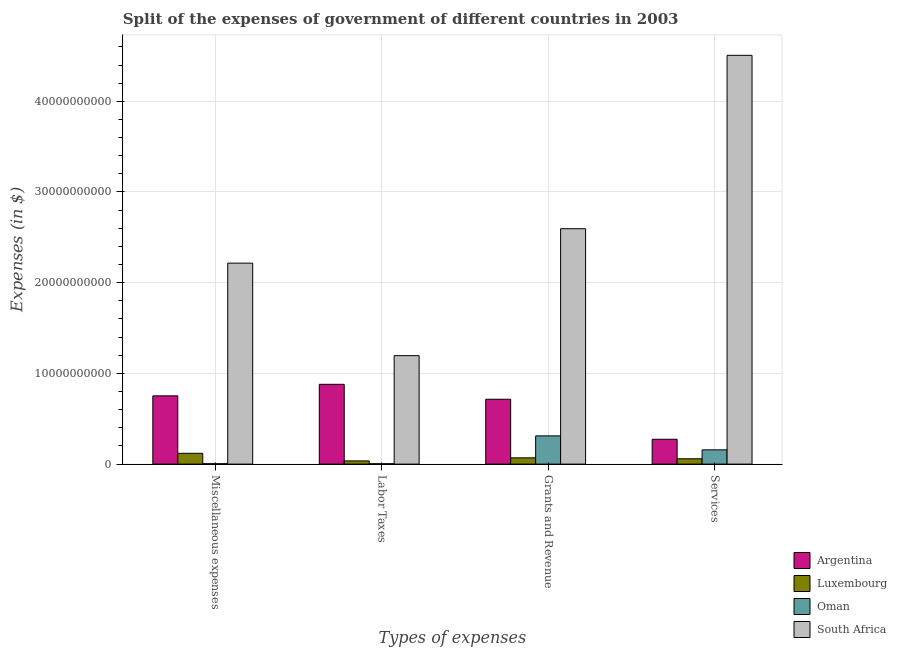How many different coloured bars are there?
Make the answer very short. 4. Are the number of bars on each tick of the X-axis equal?
Your response must be concise. Yes. How many bars are there on the 2nd tick from the left?
Provide a short and direct response. 4. How many bars are there on the 2nd tick from the right?
Ensure brevity in your answer.  4. What is the label of the 2nd group of bars from the left?
Make the answer very short. Labor Taxes. What is the amount spent on grants and revenue in South Africa?
Offer a very short reply. 2.60e+1. Across all countries, what is the maximum amount spent on services?
Keep it short and to the point. 4.51e+1. Across all countries, what is the minimum amount spent on labor taxes?
Keep it short and to the point. 4.31e+07. In which country was the amount spent on miscellaneous expenses maximum?
Offer a very short reply. South Africa. In which country was the amount spent on grants and revenue minimum?
Keep it short and to the point. Luxembourg. What is the total amount spent on labor taxes in the graph?
Your response must be concise. 2.12e+1. What is the difference between the amount spent on labor taxes in Luxembourg and that in Oman?
Your answer should be compact. 3.11e+08. What is the difference between the amount spent on labor taxes in Luxembourg and the amount spent on miscellaneous expenses in Oman?
Provide a succinct answer. 3.12e+08. What is the average amount spent on grants and revenue per country?
Your answer should be very brief. 9.23e+09. What is the difference between the amount spent on labor taxes and amount spent on grants and revenue in Oman?
Make the answer very short. -3.07e+09. In how many countries, is the amount spent on labor taxes greater than 22000000000 $?
Give a very brief answer. 0. What is the ratio of the amount spent on grants and revenue in Oman to that in Luxembourg?
Provide a short and direct response. 4.5. Is the amount spent on services in Argentina less than that in Oman?
Provide a short and direct response. No. Is the difference between the amount spent on miscellaneous expenses in Oman and Argentina greater than the difference between the amount spent on labor taxes in Oman and Argentina?
Your answer should be compact. Yes. What is the difference between the highest and the second highest amount spent on grants and revenue?
Your response must be concise. 1.88e+1. What is the difference between the highest and the lowest amount spent on services?
Your answer should be compact. 4.45e+1. What does the 4th bar from the right in Labor Taxes represents?
Offer a very short reply. Argentina. Is it the case that in every country, the sum of the amount spent on miscellaneous expenses and amount spent on labor taxes is greater than the amount spent on grants and revenue?
Your answer should be compact. No. How many bars are there?
Keep it short and to the point. 16. Are all the bars in the graph horizontal?
Offer a terse response. No. How many countries are there in the graph?
Your answer should be compact. 4. What is the difference between two consecutive major ticks on the Y-axis?
Offer a very short reply. 1.00e+1. Are the values on the major ticks of Y-axis written in scientific E-notation?
Provide a short and direct response. No. Where does the legend appear in the graph?
Your answer should be very brief. Bottom right. How are the legend labels stacked?
Provide a succinct answer. Vertical. What is the title of the graph?
Keep it short and to the point. Split of the expenses of government of different countries in 2003. What is the label or title of the X-axis?
Offer a terse response. Types of expenses. What is the label or title of the Y-axis?
Ensure brevity in your answer.  Expenses (in $). What is the Expenses (in $) in Argentina in Miscellaneous expenses?
Your answer should be very brief. 7.53e+09. What is the Expenses (in $) in Luxembourg in Miscellaneous expenses?
Your answer should be compact. 1.19e+09. What is the Expenses (in $) in Oman in Miscellaneous expenses?
Provide a succinct answer. 4.27e+07. What is the Expenses (in $) of South Africa in Miscellaneous expenses?
Your response must be concise. 2.22e+1. What is the Expenses (in $) of Argentina in Labor Taxes?
Offer a very short reply. 8.80e+09. What is the Expenses (in $) in Luxembourg in Labor Taxes?
Give a very brief answer. 3.54e+08. What is the Expenses (in $) of Oman in Labor Taxes?
Your answer should be compact. 4.31e+07. What is the Expenses (in $) of South Africa in Labor Taxes?
Offer a very short reply. 1.20e+1. What is the Expenses (in $) of Argentina in Grants and Revenue?
Offer a terse response. 7.15e+09. What is the Expenses (in $) in Luxembourg in Grants and Revenue?
Your answer should be very brief. 6.93e+08. What is the Expenses (in $) in Oman in Grants and Revenue?
Ensure brevity in your answer.  3.11e+09. What is the Expenses (in $) of South Africa in Grants and Revenue?
Provide a short and direct response. 2.60e+1. What is the Expenses (in $) in Argentina in Services?
Make the answer very short. 2.74e+09. What is the Expenses (in $) in Luxembourg in Services?
Keep it short and to the point. 5.89e+08. What is the Expenses (in $) in Oman in Services?
Make the answer very short. 1.57e+09. What is the Expenses (in $) in South Africa in Services?
Your response must be concise. 4.51e+1. Across all Types of expenses, what is the maximum Expenses (in $) of Argentina?
Keep it short and to the point. 8.80e+09. Across all Types of expenses, what is the maximum Expenses (in $) of Luxembourg?
Offer a terse response. 1.19e+09. Across all Types of expenses, what is the maximum Expenses (in $) in Oman?
Ensure brevity in your answer.  3.11e+09. Across all Types of expenses, what is the maximum Expenses (in $) in South Africa?
Give a very brief answer. 4.51e+1. Across all Types of expenses, what is the minimum Expenses (in $) of Argentina?
Give a very brief answer. 2.74e+09. Across all Types of expenses, what is the minimum Expenses (in $) of Luxembourg?
Keep it short and to the point. 3.54e+08. Across all Types of expenses, what is the minimum Expenses (in $) in Oman?
Offer a terse response. 4.27e+07. Across all Types of expenses, what is the minimum Expenses (in $) in South Africa?
Your answer should be compact. 1.20e+1. What is the total Expenses (in $) of Argentina in the graph?
Ensure brevity in your answer.  2.62e+1. What is the total Expenses (in $) in Luxembourg in the graph?
Provide a short and direct response. 2.83e+09. What is the total Expenses (in $) in Oman in the graph?
Provide a short and direct response. 4.77e+09. What is the total Expenses (in $) of South Africa in the graph?
Offer a terse response. 1.05e+11. What is the difference between the Expenses (in $) of Argentina in Miscellaneous expenses and that in Labor Taxes?
Provide a short and direct response. -1.27e+09. What is the difference between the Expenses (in $) of Luxembourg in Miscellaneous expenses and that in Labor Taxes?
Make the answer very short. 8.38e+08. What is the difference between the Expenses (in $) of Oman in Miscellaneous expenses and that in Labor Taxes?
Your response must be concise. -4.00e+05. What is the difference between the Expenses (in $) in South Africa in Miscellaneous expenses and that in Labor Taxes?
Give a very brief answer. 1.02e+1. What is the difference between the Expenses (in $) of Argentina in Miscellaneous expenses and that in Grants and Revenue?
Make the answer very short. 3.75e+08. What is the difference between the Expenses (in $) of Luxembourg in Miscellaneous expenses and that in Grants and Revenue?
Your answer should be compact. 5.00e+08. What is the difference between the Expenses (in $) of Oman in Miscellaneous expenses and that in Grants and Revenue?
Your answer should be very brief. -3.07e+09. What is the difference between the Expenses (in $) of South Africa in Miscellaneous expenses and that in Grants and Revenue?
Give a very brief answer. -3.80e+09. What is the difference between the Expenses (in $) of Argentina in Miscellaneous expenses and that in Services?
Provide a short and direct response. 4.79e+09. What is the difference between the Expenses (in $) in Luxembourg in Miscellaneous expenses and that in Services?
Ensure brevity in your answer.  6.04e+08. What is the difference between the Expenses (in $) of Oman in Miscellaneous expenses and that in Services?
Offer a very short reply. -1.53e+09. What is the difference between the Expenses (in $) in South Africa in Miscellaneous expenses and that in Services?
Offer a very short reply. -2.29e+1. What is the difference between the Expenses (in $) in Argentina in Labor Taxes and that in Grants and Revenue?
Ensure brevity in your answer.  1.65e+09. What is the difference between the Expenses (in $) of Luxembourg in Labor Taxes and that in Grants and Revenue?
Your answer should be compact. -3.38e+08. What is the difference between the Expenses (in $) in Oman in Labor Taxes and that in Grants and Revenue?
Your answer should be very brief. -3.07e+09. What is the difference between the Expenses (in $) of South Africa in Labor Taxes and that in Grants and Revenue?
Make the answer very short. -1.40e+1. What is the difference between the Expenses (in $) in Argentina in Labor Taxes and that in Services?
Offer a terse response. 6.06e+09. What is the difference between the Expenses (in $) of Luxembourg in Labor Taxes and that in Services?
Your answer should be very brief. -2.34e+08. What is the difference between the Expenses (in $) in Oman in Labor Taxes and that in Services?
Ensure brevity in your answer.  -1.53e+09. What is the difference between the Expenses (in $) in South Africa in Labor Taxes and that in Services?
Provide a short and direct response. -3.31e+1. What is the difference between the Expenses (in $) of Argentina in Grants and Revenue and that in Services?
Ensure brevity in your answer.  4.41e+09. What is the difference between the Expenses (in $) in Luxembourg in Grants and Revenue and that in Services?
Give a very brief answer. 1.04e+08. What is the difference between the Expenses (in $) in Oman in Grants and Revenue and that in Services?
Ensure brevity in your answer.  1.54e+09. What is the difference between the Expenses (in $) in South Africa in Grants and Revenue and that in Services?
Provide a succinct answer. -1.91e+1. What is the difference between the Expenses (in $) in Argentina in Miscellaneous expenses and the Expenses (in $) in Luxembourg in Labor Taxes?
Provide a short and direct response. 7.17e+09. What is the difference between the Expenses (in $) of Argentina in Miscellaneous expenses and the Expenses (in $) of Oman in Labor Taxes?
Provide a short and direct response. 7.48e+09. What is the difference between the Expenses (in $) in Argentina in Miscellaneous expenses and the Expenses (in $) in South Africa in Labor Taxes?
Make the answer very short. -4.43e+09. What is the difference between the Expenses (in $) of Luxembourg in Miscellaneous expenses and the Expenses (in $) of Oman in Labor Taxes?
Make the answer very short. 1.15e+09. What is the difference between the Expenses (in $) of Luxembourg in Miscellaneous expenses and the Expenses (in $) of South Africa in Labor Taxes?
Your answer should be compact. -1.08e+1. What is the difference between the Expenses (in $) in Oman in Miscellaneous expenses and the Expenses (in $) in South Africa in Labor Taxes?
Provide a succinct answer. -1.19e+1. What is the difference between the Expenses (in $) of Argentina in Miscellaneous expenses and the Expenses (in $) of Luxembourg in Grants and Revenue?
Your answer should be very brief. 6.83e+09. What is the difference between the Expenses (in $) in Argentina in Miscellaneous expenses and the Expenses (in $) in Oman in Grants and Revenue?
Your response must be concise. 4.41e+09. What is the difference between the Expenses (in $) in Argentina in Miscellaneous expenses and the Expenses (in $) in South Africa in Grants and Revenue?
Provide a succinct answer. -1.84e+1. What is the difference between the Expenses (in $) in Luxembourg in Miscellaneous expenses and the Expenses (in $) in Oman in Grants and Revenue?
Offer a very short reply. -1.92e+09. What is the difference between the Expenses (in $) of Luxembourg in Miscellaneous expenses and the Expenses (in $) of South Africa in Grants and Revenue?
Offer a terse response. -2.48e+1. What is the difference between the Expenses (in $) of Oman in Miscellaneous expenses and the Expenses (in $) of South Africa in Grants and Revenue?
Your answer should be compact. -2.59e+1. What is the difference between the Expenses (in $) of Argentina in Miscellaneous expenses and the Expenses (in $) of Luxembourg in Services?
Your answer should be very brief. 6.94e+09. What is the difference between the Expenses (in $) of Argentina in Miscellaneous expenses and the Expenses (in $) of Oman in Services?
Your response must be concise. 5.95e+09. What is the difference between the Expenses (in $) in Argentina in Miscellaneous expenses and the Expenses (in $) in South Africa in Services?
Your response must be concise. -3.75e+1. What is the difference between the Expenses (in $) in Luxembourg in Miscellaneous expenses and the Expenses (in $) in Oman in Services?
Your response must be concise. -3.81e+08. What is the difference between the Expenses (in $) of Luxembourg in Miscellaneous expenses and the Expenses (in $) of South Africa in Services?
Provide a succinct answer. -4.39e+1. What is the difference between the Expenses (in $) in Oman in Miscellaneous expenses and the Expenses (in $) in South Africa in Services?
Make the answer very short. -4.50e+1. What is the difference between the Expenses (in $) of Argentina in Labor Taxes and the Expenses (in $) of Luxembourg in Grants and Revenue?
Your answer should be compact. 8.10e+09. What is the difference between the Expenses (in $) in Argentina in Labor Taxes and the Expenses (in $) in Oman in Grants and Revenue?
Provide a short and direct response. 5.68e+09. What is the difference between the Expenses (in $) in Argentina in Labor Taxes and the Expenses (in $) in South Africa in Grants and Revenue?
Provide a succinct answer. -1.72e+1. What is the difference between the Expenses (in $) in Luxembourg in Labor Taxes and the Expenses (in $) in Oman in Grants and Revenue?
Offer a very short reply. -2.76e+09. What is the difference between the Expenses (in $) of Luxembourg in Labor Taxes and the Expenses (in $) of South Africa in Grants and Revenue?
Offer a very short reply. -2.56e+1. What is the difference between the Expenses (in $) of Oman in Labor Taxes and the Expenses (in $) of South Africa in Grants and Revenue?
Your answer should be compact. -2.59e+1. What is the difference between the Expenses (in $) of Argentina in Labor Taxes and the Expenses (in $) of Luxembourg in Services?
Ensure brevity in your answer.  8.21e+09. What is the difference between the Expenses (in $) of Argentina in Labor Taxes and the Expenses (in $) of Oman in Services?
Give a very brief answer. 7.22e+09. What is the difference between the Expenses (in $) of Argentina in Labor Taxes and the Expenses (in $) of South Africa in Services?
Offer a very short reply. -3.63e+1. What is the difference between the Expenses (in $) of Luxembourg in Labor Taxes and the Expenses (in $) of Oman in Services?
Your answer should be very brief. -1.22e+09. What is the difference between the Expenses (in $) in Luxembourg in Labor Taxes and the Expenses (in $) in South Africa in Services?
Give a very brief answer. -4.47e+1. What is the difference between the Expenses (in $) in Oman in Labor Taxes and the Expenses (in $) in South Africa in Services?
Your response must be concise. -4.50e+1. What is the difference between the Expenses (in $) in Argentina in Grants and Revenue and the Expenses (in $) in Luxembourg in Services?
Provide a short and direct response. 6.56e+09. What is the difference between the Expenses (in $) of Argentina in Grants and Revenue and the Expenses (in $) of Oman in Services?
Offer a very short reply. 5.58e+09. What is the difference between the Expenses (in $) in Argentina in Grants and Revenue and the Expenses (in $) in South Africa in Services?
Your answer should be compact. -3.79e+1. What is the difference between the Expenses (in $) of Luxembourg in Grants and Revenue and the Expenses (in $) of Oman in Services?
Your answer should be compact. -8.81e+08. What is the difference between the Expenses (in $) in Luxembourg in Grants and Revenue and the Expenses (in $) in South Africa in Services?
Provide a succinct answer. -4.44e+1. What is the difference between the Expenses (in $) in Oman in Grants and Revenue and the Expenses (in $) in South Africa in Services?
Make the answer very short. -4.20e+1. What is the average Expenses (in $) in Argentina per Types of expenses?
Your response must be concise. 6.55e+09. What is the average Expenses (in $) of Luxembourg per Types of expenses?
Offer a very short reply. 7.07e+08. What is the average Expenses (in $) of Oman per Types of expenses?
Your answer should be compact. 1.19e+09. What is the average Expenses (in $) in South Africa per Types of expenses?
Ensure brevity in your answer.  2.63e+1. What is the difference between the Expenses (in $) of Argentina and Expenses (in $) of Luxembourg in Miscellaneous expenses?
Ensure brevity in your answer.  6.33e+09. What is the difference between the Expenses (in $) of Argentina and Expenses (in $) of Oman in Miscellaneous expenses?
Your answer should be compact. 7.48e+09. What is the difference between the Expenses (in $) of Argentina and Expenses (in $) of South Africa in Miscellaneous expenses?
Offer a terse response. -1.46e+1. What is the difference between the Expenses (in $) in Luxembourg and Expenses (in $) in Oman in Miscellaneous expenses?
Offer a terse response. 1.15e+09. What is the difference between the Expenses (in $) of Luxembourg and Expenses (in $) of South Africa in Miscellaneous expenses?
Provide a succinct answer. -2.10e+1. What is the difference between the Expenses (in $) of Oman and Expenses (in $) of South Africa in Miscellaneous expenses?
Give a very brief answer. -2.21e+1. What is the difference between the Expenses (in $) in Argentina and Expenses (in $) in Luxembourg in Labor Taxes?
Give a very brief answer. 8.44e+09. What is the difference between the Expenses (in $) of Argentina and Expenses (in $) of Oman in Labor Taxes?
Your answer should be very brief. 8.75e+09. What is the difference between the Expenses (in $) in Argentina and Expenses (in $) in South Africa in Labor Taxes?
Your response must be concise. -3.16e+09. What is the difference between the Expenses (in $) in Luxembourg and Expenses (in $) in Oman in Labor Taxes?
Provide a succinct answer. 3.11e+08. What is the difference between the Expenses (in $) in Luxembourg and Expenses (in $) in South Africa in Labor Taxes?
Your answer should be compact. -1.16e+1. What is the difference between the Expenses (in $) of Oman and Expenses (in $) of South Africa in Labor Taxes?
Offer a terse response. -1.19e+1. What is the difference between the Expenses (in $) of Argentina and Expenses (in $) of Luxembourg in Grants and Revenue?
Provide a short and direct response. 6.46e+09. What is the difference between the Expenses (in $) of Argentina and Expenses (in $) of Oman in Grants and Revenue?
Provide a succinct answer. 4.04e+09. What is the difference between the Expenses (in $) of Argentina and Expenses (in $) of South Africa in Grants and Revenue?
Give a very brief answer. -1.88e+1. What is the difference between the Expenses (in $) in Luxembourg and Expenses (in $) in Oman in Grants and Revenue?
Your answer should be very brief. -2.42e+09. What is the difference between the Expenses (in $) of Luxembourg and Expenses (in $) of South Africa in Grants and Revenue?
Your answer should be compact. -2.53e+1. What is the difference between the Expenses (in $) of Oman and Expenses (in $) of South Africa in Grants and Revenue?
Make the answer very short. -2.28e+1. What is the difference between the Expenses (in $) of Argentina and Expenses (in $) of Luxembourg in Services?
Provide a short and direct response. 2.15e+09. What is the difference between the Expenses (in $) in Argentina and Expenses (in $) in Oman in Services?
Make the answer very short. 1.17e+09. What is the difference between the Expenses (in $) in Argentina and Expenses (in $) in South Africa in Services?
Ensure brevity in your answer.  -4.23e+1. What is the difference between the Expenses (in $) of Luxembourg and Expenses (in $) of Oman in Services?
Keep it short and to the point. -9.85e+08. What is the difference between the Expenses (in $) in Luxembourg and Expenses (in $) in South Africa in Services?
Offer a very short reply. -4.45e+1. What is the difference between the Expenses (in $) in Oman and Expenses (in $) in South Africa in Services?
Make the answer very short. -4.35e+1. What is the ratio of the Expenses (in $) in Argentina in Miscellaneous expenses to that in Labor Taxes?
Give a very brief answer. 0.86. What is the ratio of the Expenses (in $) in Luxembourg in Miscellaneous expenses to that in Labor Taxes?
Provide a short and direct response. 3.37. What is the ratio of the Expenses (in $) in South Africa in Miscellaneous expenses to that in Labor Taxes?
Your response must be concise. 1.85. What is the ratio of the Expenses (in $) in Argentina in Miscellaneous expenses to that in Grants and Revenue?
Your response must be concise. 1.05. What is the ratio of the Expenses (in $) of Luxembourg in Miscellaneous expenses to that in Grants and Revenue?
Offer a very short reply. 1.72. What is the ratio of the Expenses (in $) in Oman in Miscellaneous expenses to that in Grants and Revenue?
Provide a succinct answer. 0.01. What is the ratio of the Expenses (in $) in South Africa in Miscellaneous expenses to that in Grants and Revenue?
Provide a succinct answer. 0.85. What is the ratio of the Expenses (in $) in Argentina in Miscellaneous expenses to that in Services?
Offer a terse response. 2.75. What is the ratio of the Expenses (in $) in Luxembourg in Miscellaneous expenses to that in Services?
Ensure brevity in your answer.  2.03. What is the ratio of the Expenses (in $) of Oman in Miscellaneous expenses to that in Services?
Offer a very short reply. 0.03. What is the ratio of the Expenses (in $) in South Africa in Miscellaneous expenses to that in Services?
Your response must be concise. 0.49. What is the ratio of the Expenses (in $) in Argentina in Labor Taxes to that in Grants and Revenue?
Keep it short and to the point. 1.23. What is the ratio of the Expenses (in $) in Luxembourg in Labor Taxes to that in Grants and Revenue?
Your response must be concise. 0.51. What is the ratio of the Expenses (in $) of Oman in Labor Taxes to that in Grants and Revenue?
Give a very brief answer. 0.01. What is the ratio of the Expenses (in $) of South Africa in Labor Taxes to that in Grants and Revenue?
Make the answer very short. 0.46. What is the ratio of the Expenses (in $) in Argentina in Labor Taxes to that in Services?
Provide a succinct answer. 3.21. What is the ratio of the Expenses (in $) of Luxembourg in Labor Taxes to that in Services?
Give a very brief answer. 0.6. What is the ratio of the Expenses (in $) of Oman in Labor Taxes to that in Services?
Your answer should be compact. 0.03. What is the ratio of the Expenses (in $) of South Africa in Labor Taxes to that in Services?
Give a very brief answer. 0.27. What is the ratio of the Expenses (in $) of Argentina in Grants and Revenue to that in Services?
Offer a very short reply. 2.61. What is the ratio of the Expenses (in $) in Luxembourg in Grants and Revenue to that in Services?
Your response must be concise. 1.18. What is the ratio of the Expenses (in $) of Oman in Grants and Revenue to that in Services?
Your answer should be very brief. 1.98. What is the ratio of the Expenses (in $) in South Africa in Grants and Revenue to that in Services?
Provide a succinct answer. 0.58. What is the difference between the highest and the second highest Expenses (in $) in Argentina?
Make the answer very short. 1.27e+09. What is the difference between the highest and the second highest Expenses (in $) of Luxembourg?
Your answer should be very brief. 5.00e+08. What is the difference between the highest and the second highest Expenses (in $) of Oman?
Ensure brevity in your answer.  1.54e+09. What is the difference between the highest and the second highest Expenses (in $) in South Africa?
Ensure brevity in your answer.  1.91e+1. What is the difference between the highest and the lowest Expenses (in $) of Argentina?
Give a very brief answer. 6.06e+09. What is the difference between the highest and the lowest Expenses (in $) in Luxembourg?
Provide a succinct answer. 8.38e+08. What is the difference between the highest and the lowest Expenses (in $) in Oman?
Make the answer very short. 3.07e+09. What is the difference between the highest and the lowest Expenses (in $) of South Africa?
Offer a terse response. 3.31e+1. 